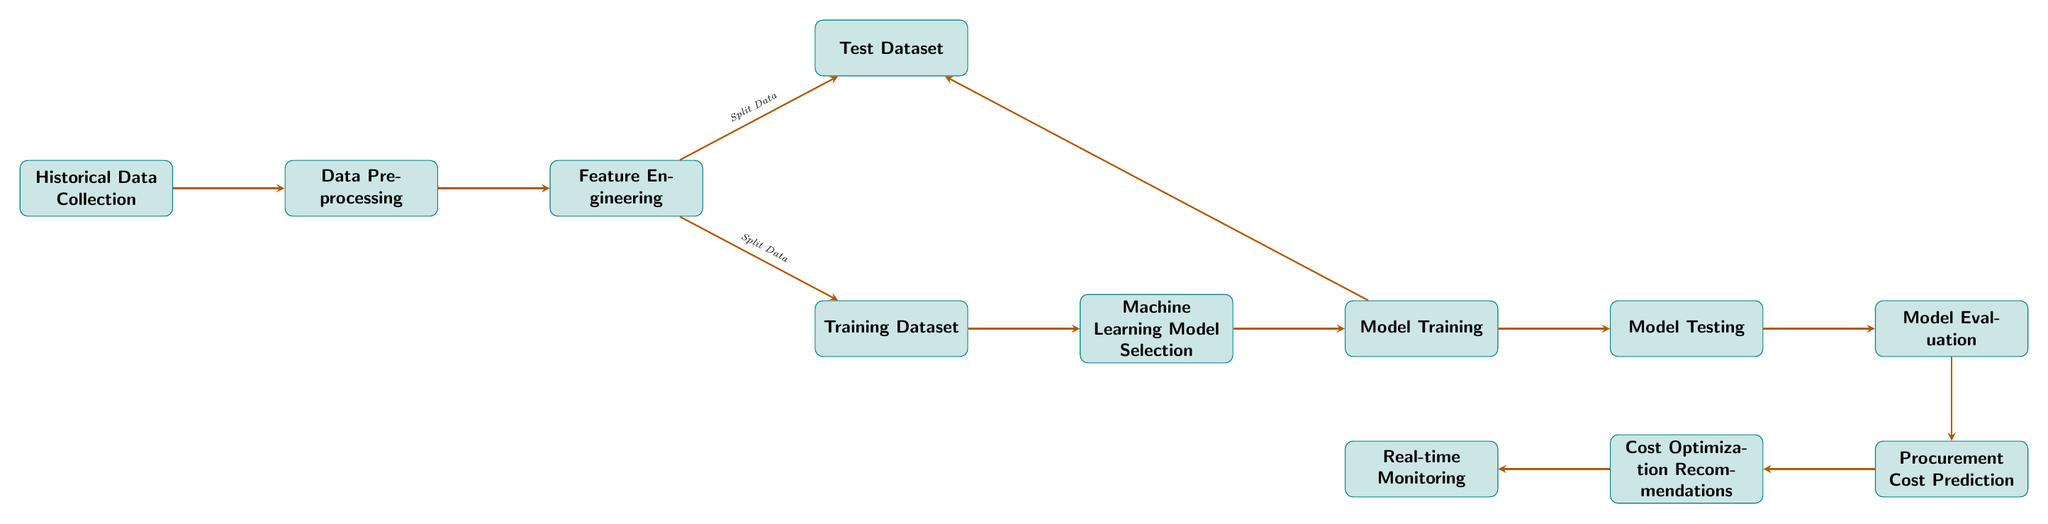What is the first step in the process? The first node in the diagram is labeled "Historical Data Collection," indicating it is the starting point of the process.
Answer: Historical Data Collection How many nodes are there in total? By counting the nodes in the diagram, we find there are twelve distinct boxes, each representing different steps in the process.
Answer: Twelve What is the output of the node "Model Evaluation"? The node labeled "Model Evaluation" directs to "Procurement Cost Prediction," indicating that the output of the evaluation leads to cost predictions.
Answer: Procurement Cost Prediction Which node leads to "Real-time Monitoring"? The "Cost Optimization Recommendations" node directly points to "Real-time Monitoring," indicating that recommendations feed into this monitoring process.
Answer: Cost Optimization Recommendations How many splits occur in the "Feature Engineering" step? The "Feature Engineering" node is connected to both the "Training Dataset" and the "Test Dataset," meaning there are two splits happening in this step.
Answer: Two What is the relationship between "Model Training" and "Model Testing"? The "Model Training" node has arrows leading to both "Test Dataset" and "Model Testing," indicating that training must occur before testing can take place.
Answer: Training occurs before testing What follows after "Procurement Cost Prediction"? The "Procurement Cost Prediction" node directs to "Cost Optimization Recommendations," showing that cost predictions lead directly to optimization suggestions.
Answer: Cost Optimization Recommendations What connects "Model Testing" and "Model Evaluation"? "Model Testing" leads directly into "Model Evaluation," meaning that testing outcomes are evaluated as a part of the process.
Answer: Model Testing leads to Model Evaluation 